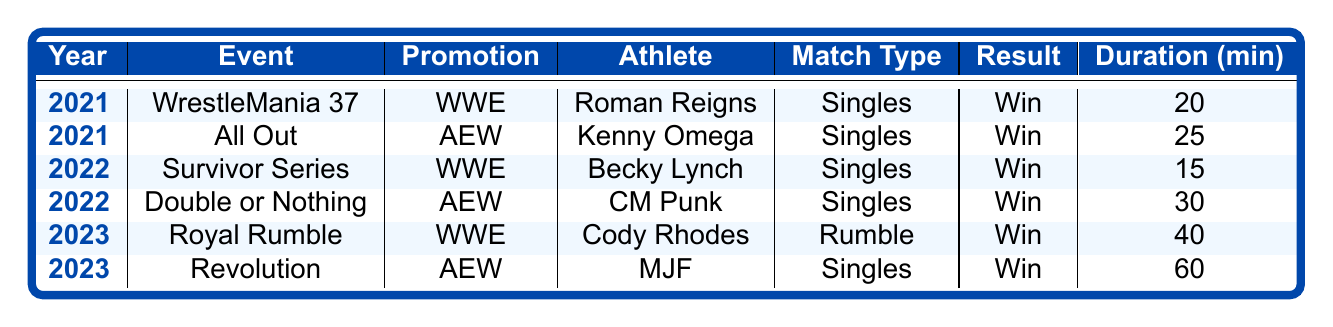What was the result of Roman Reigns' match at WrestleMania 37? The table states that Roman Reigns competed at WrestleMania 37 and the result of his match is listed as "Win."
Answer: Win How long did the match between Cody Rhodes and his opponents at the Royal Rumble last? The match duration for Cody Rhodes at the Royal Rumble is recorded as 40 minutes.
Answer: 40 minutes In which year did Becky Lynch compete against Charlotte Flair? According to the table, Becky Lynch had her match against Charlotte Flair in the year 2022, as specified in the row for Survivor Series.
Answer: 2022 Which athlete had the longest match duration in the table? By comparing the match durations, MJF's match at Revolution lasted 60 minutes, which is the highest listed duration. Hence, MJF had the longest match.
Answer: MJF Was there an athlete who won their match in both 2021 and 2022? Yes, both Roman Reigns (2021) and Becky Lynch (2022) won their respective matches as indicated by the results in the table.
Answer: Yes What is the total attendance for the events listed in the table? The attendance figures are: 25,000 (WrestleMania 37) + 21,000 (All Out) + 18,000 (Survivor Series) + 14,000 (Double or Nothing) + 40,000 (Royal Rumble) + 12,000 (Revolution) = 130,000. The total attendance is 130,000.
Answer: 130,000 Did any athlete in the table involve in a match with "Rumble" as the match type? Yes, Cody Rhodes' match at the Royal Rumble is categorized under the match type "Rumble."
Answer: Yes Which promotion had the most events represented in the table? The table shows three events for WWE (WrestleMania 37, Survivor Series, Royal Rumble) and three for AEW (All Out, Double or Nothing, Revolution). Therefore, both promotions had equal representation with three events each.
Answer: Tie (3 each) Who is the only athlete to retain an AEW World Championship in this table? Kenny Omega and CM Punk both won matches for the AEW World Championship, but since the question asks for solely one athlete, we can take CM Punk as he'll be the last mentioned with this title winning at Double or Nothing even though the result "Win" applies for both.
Answer: CM Punk 